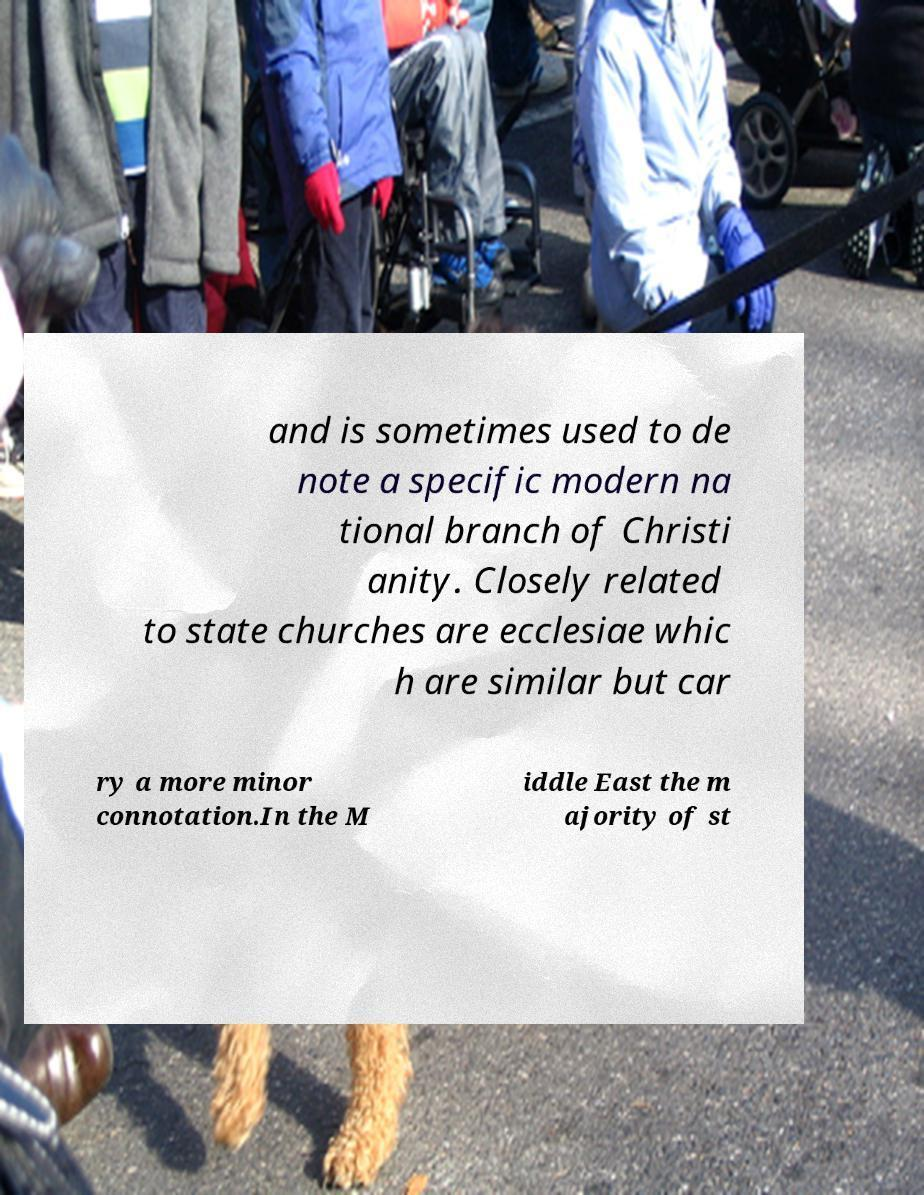Can you accurately transcribe the text from the provided image for me? and is sometimes used to de note a specific modern na tional branch of Christi anity. Closely related to state churches are ecclesiae whic h are similar but car ry a more minor connotation.In the M iddle East the m ajority of st 